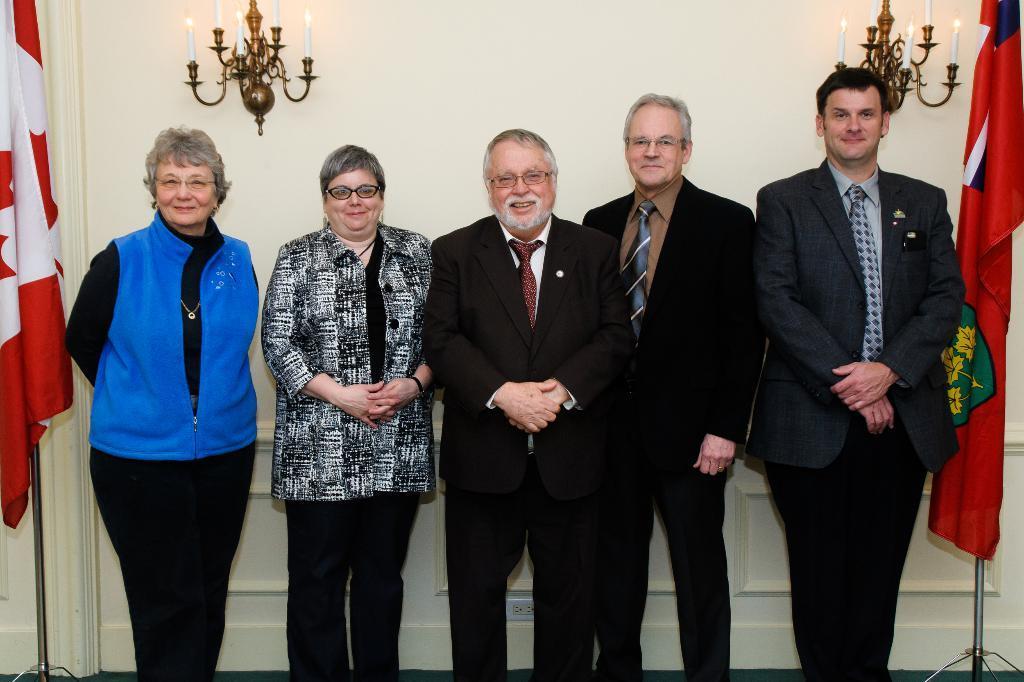Could you give a brief overview of what you see in this image? In this image I can see few people standing and wearing different color dresses. I can see flags on both-sides. Back I can see a white wall and candles is attached to the wall. 